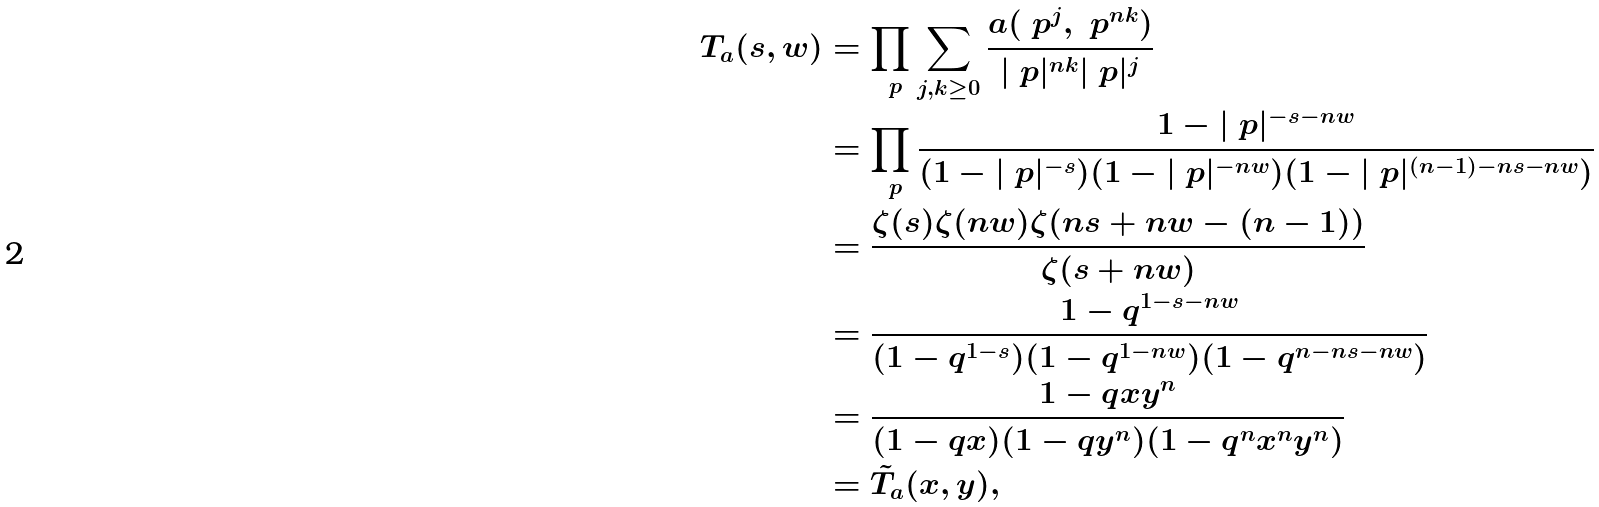Convert formula to latex. <formula><loc_0><loc_0><loc_500><loc_500>T _ { a } ( s , w ) & = \prod _ { \ p } \sum _ { j , k \geq 0 } \frac { a ( \ p ^ { j } , \ p ^ { n k } ) } { | \ p | ^ { n k } | \ p | ^ { j } } \\ & = \prod _ { \ p } \frac { 1 - | \ p | ^ { - s - n w } } { ( 1 - | \ p | ^ { - s } ) ( 1 - | \ p | ^ { - n w } ) ( 1 - | \ p | ^ { ( n - 1 ) - n s - n w } ) } \\ & = \frac { \zeta ( s ) \zeta ( n w ) \zeta ( n s + n w - ( n - 1 ) ) } { \zeta ( s + n w ) } \\ & = \frac { 1 - q ^ { 1 - s - n w } } { ( 1 - q ^ { 1 - s } ) ( 1 - q ^ { 1 - n w } ) ( 1 - q ^ { n - n s - n w } ) } \\ & = \frac { 1 - q x y ^ { n } } { ( 1 - q x ) ( 1 - q y ^ { n } ) ( 1 - q ^ { n } x ^ { n } y ^ { n } ) } \\ & = \tilde { T } _ { a } ( x , y ) ,</formula> 